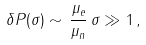Convert formula to latex. <formula><loc_0><loc_0><loc_500><loc_500>\delta P ( \sigma ) \sim \, \frac { \mu _ { e } } { \mu _ { n } } \, \sigma \gg 1 \, ,</formula> 